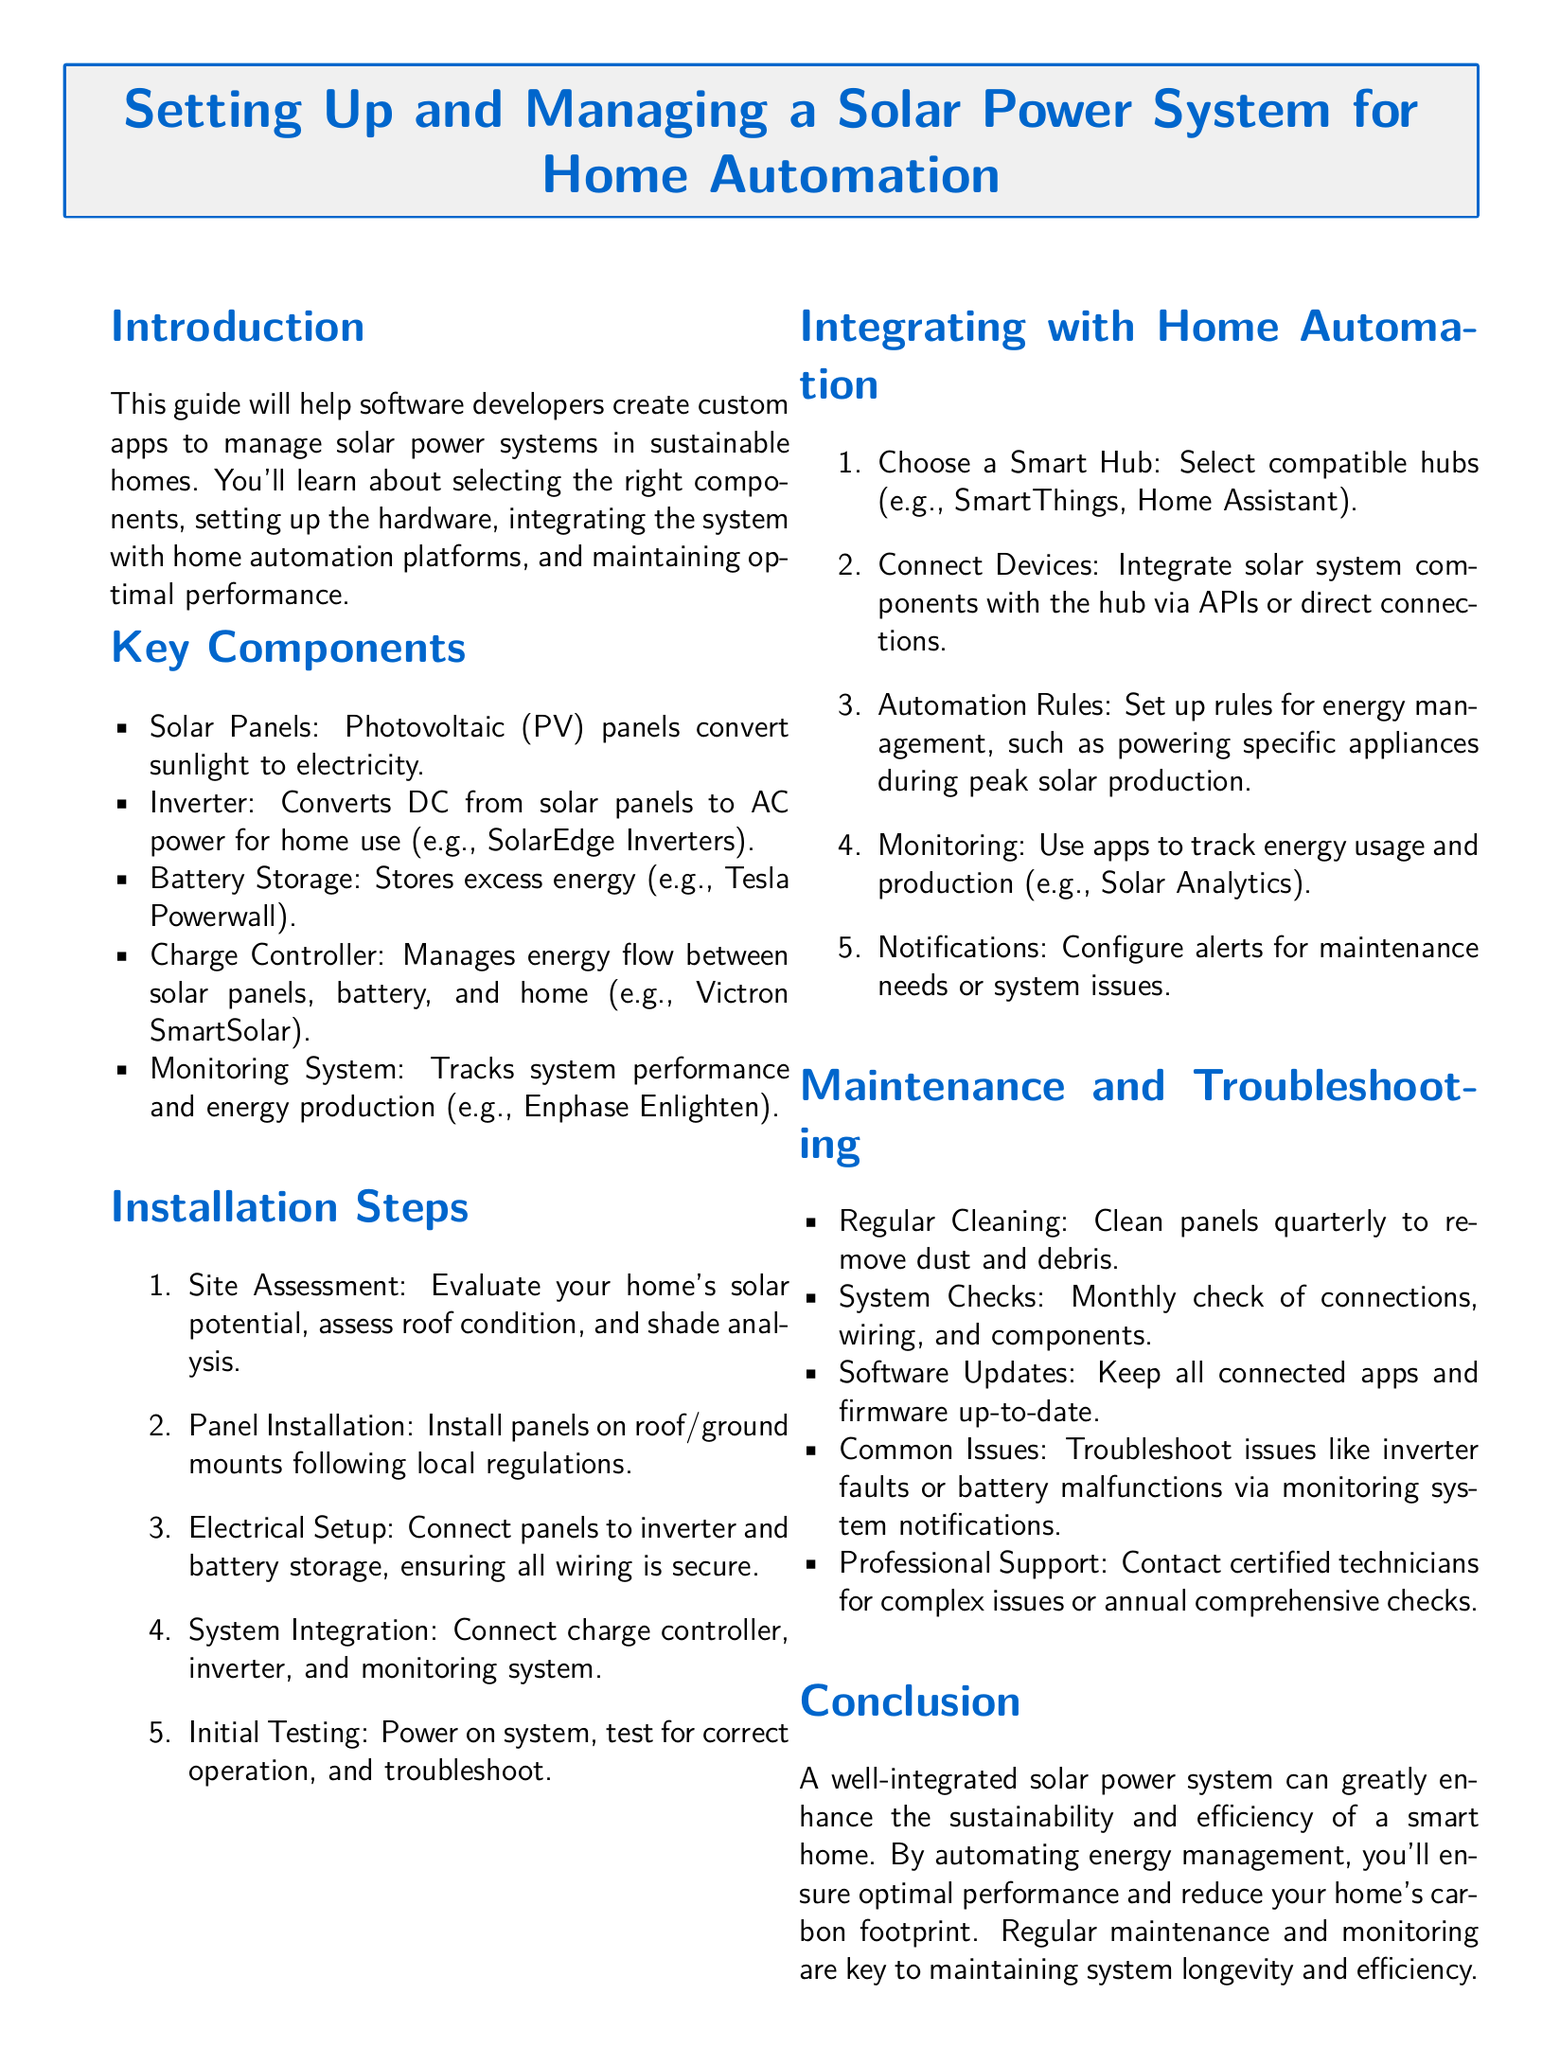What are the key components of a solar power system? The document lists the essential components necessary for a solar power system including solar panels, inverter, battery storage, charge controller, and monitoring system.
Answer: Solar Panels, Inverter, Battery Storage, Charge Controller, Monitoring System Which battery storage option is mentioned? Tesla Powerwall is presented as an example of battery storage in the document for managing excess solar energy.
Answer: Tesla Powerwall How often should solar panels be cleaned? The document suggests cleaning the panels quarterly to maintain their efficiency and performance.
Answer: Quarterly What is the initial step in the installation process? The document states that a site assessment is the first critical step in determining the feasibility of a solar power system setup.
Answer: Site Assessment What smart hub is recommended for integration? SmartThings and Home Assistant are mentioned as compatible hubs for integrating solar power systems with home automation.
Answer: SmartThings, Home Assistant What type of system checks should be performed monthly? Monthly checks of connections, wiring, and components are recommended to ensure the solar power system functions correctly.
Answer: Connections, wiring, and components What should you do if there are inverter faults? The document advises troubleshooting such issues through notifications provided by the monitoring system to understand and resolve them.
Answer: Monitoring system notifications What is emphasized as key to maintaining system longevity? The document highlights the importance of regular maintenance and monitoring in extending the life and efficiency of the solar power system.
Answer: Regular maintenance and monitoring 